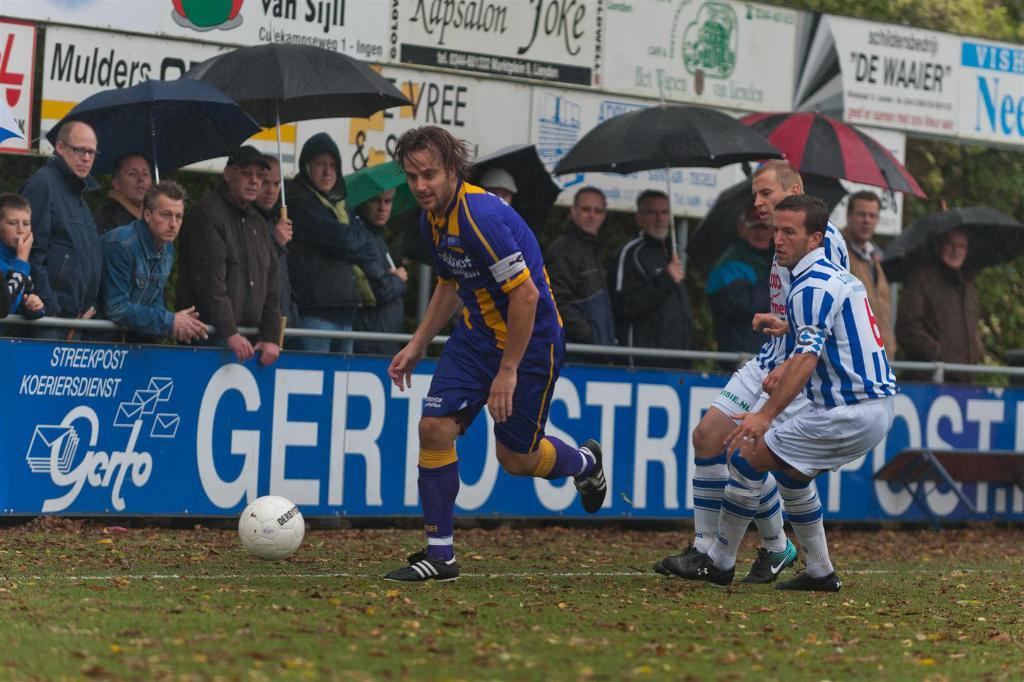<image>
Summarize the visual content of the image. Fans watch a soccer match in progress sponsored by Gerto. 